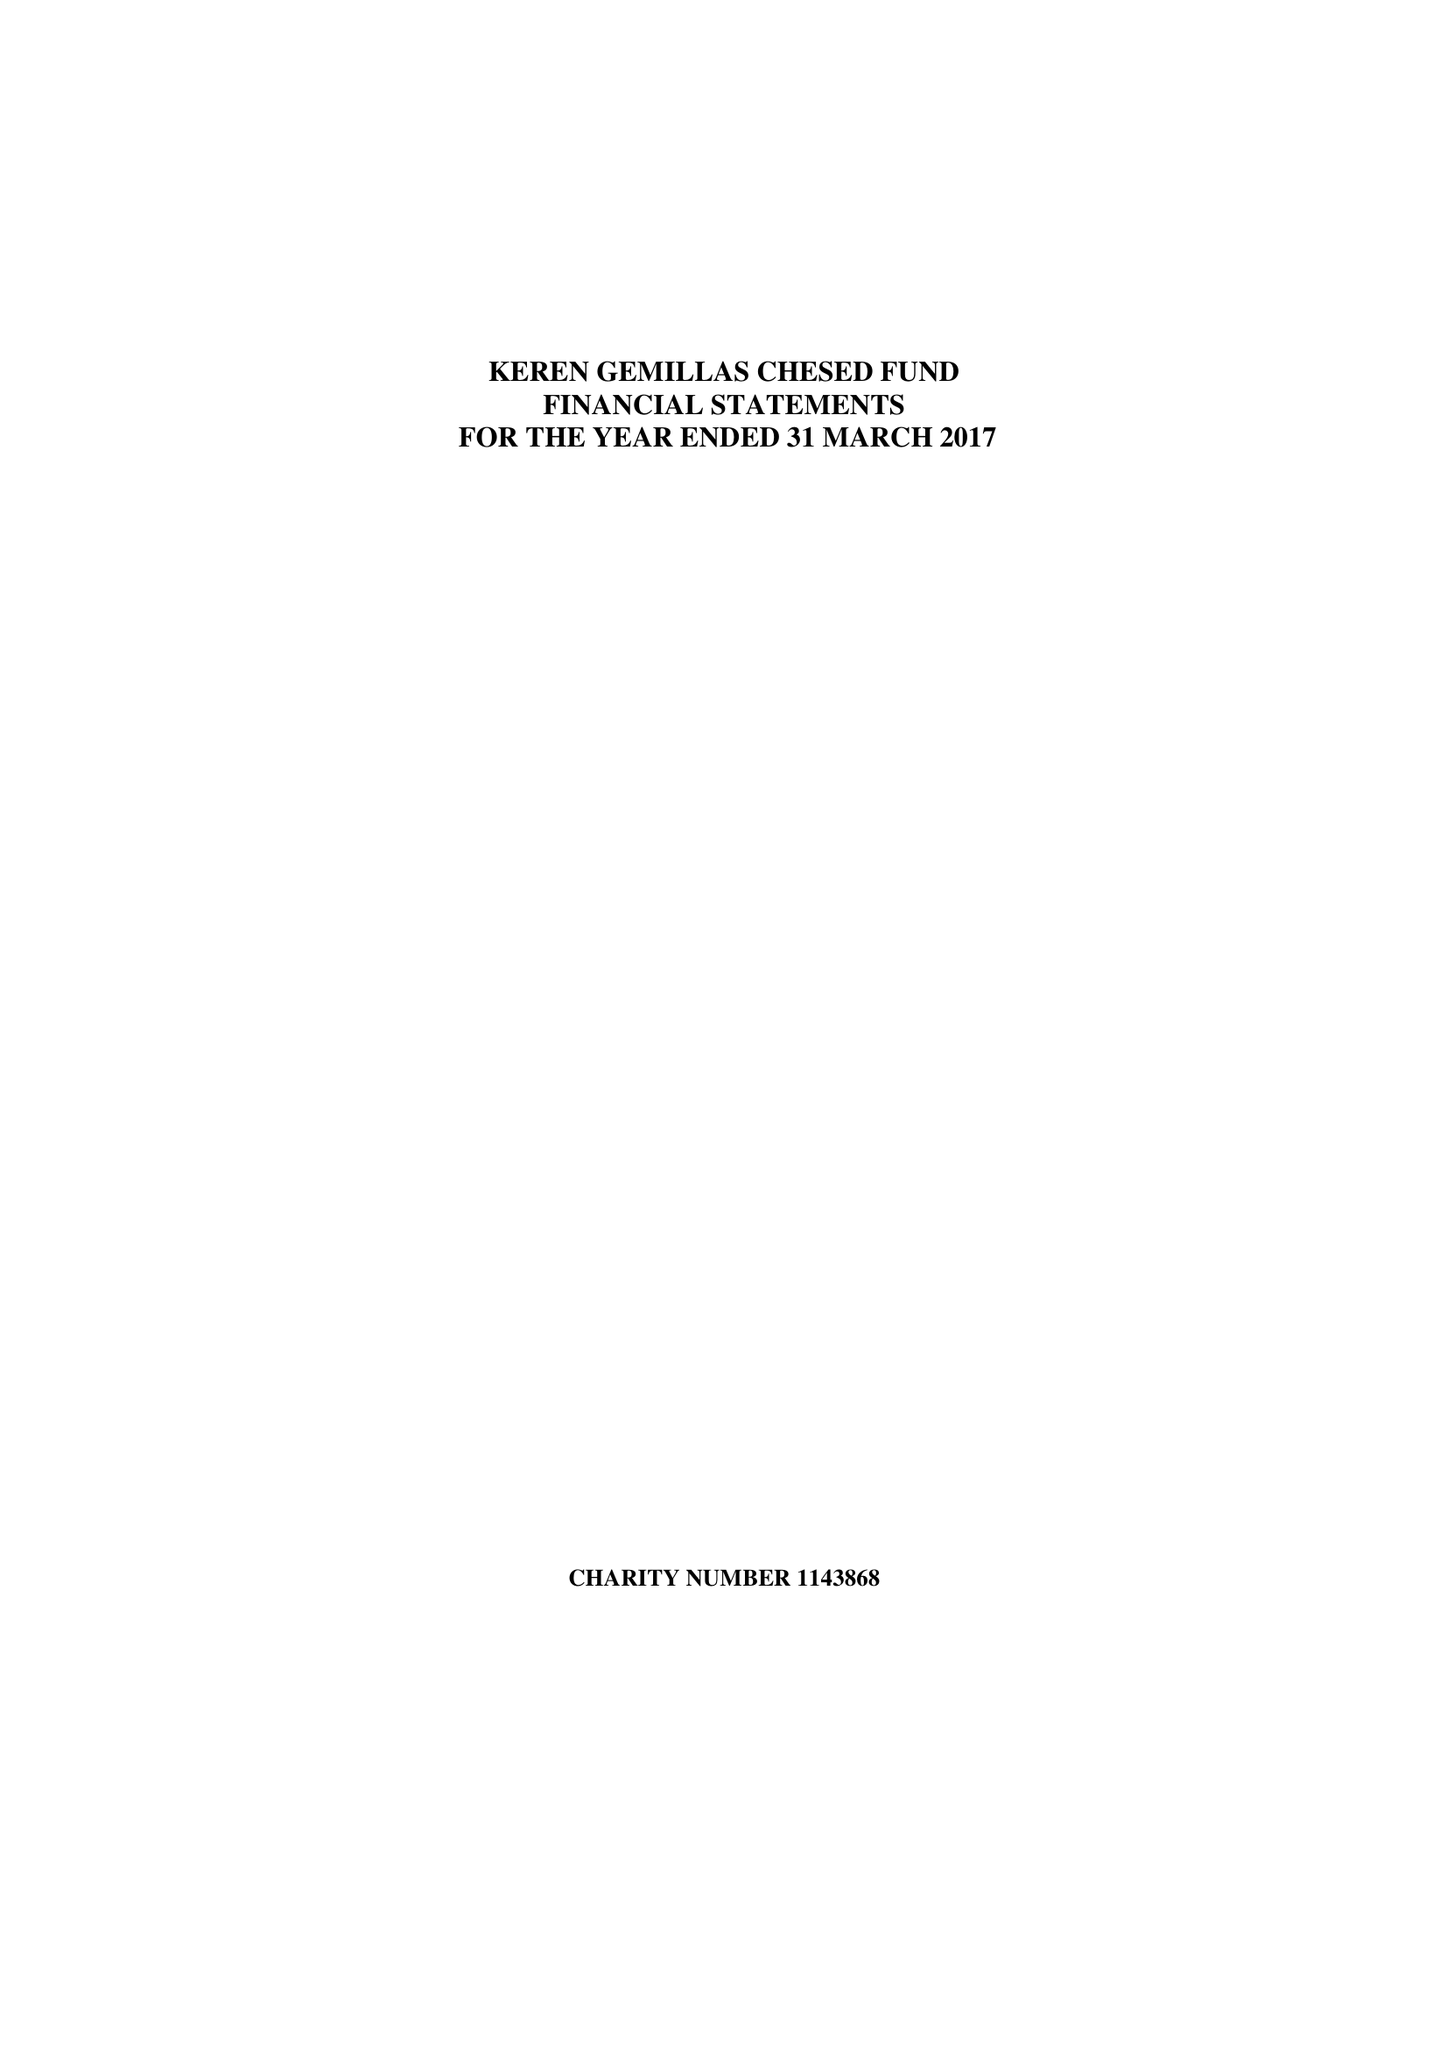What is the value for the charity_number?
Answer the question using a single word or phrase. 1143868 